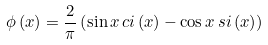Convert formula to latex. <formula><loc_0><loc_0><loc_500><loc_500>\phi \left ( x \right ) = \frac { 2 } { \pi } \left ( \sin x \, c i \left ( x \right ) - \cos x \, s i \left ( x \right ) \right )</formula> 